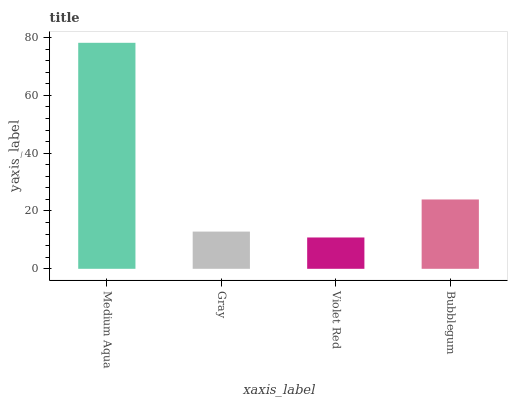Is Gray the minimum?
Answer yes or no. No. Is Gray the maximum?
Answer yes or no. No. Is Medium Aqua greater than Gray?
Answer yes or no. Yes. Is Gray less than Medium Aqua?
Answer yes or no. Yes. Is Gray greater than Medium Aqua?
Answer yes or no. No. Is Medium Aqua less than Gray?
Answer yes or no. No. Is Bubblegum the high median?
Answer yes or no. Yes. Is Gray the low median?
Answer yes or no. Yes. Is Violet Red the high median?
Answer yes or no. No. Is Violet Red the low median?
Answer yes or no. No. 